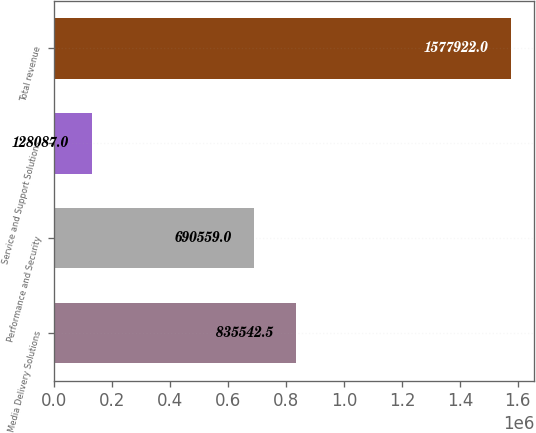<chart> <loc_0><loc_0><loc_500><loc_500><bar_chart><fcel>Media Delivery Solutions<fcel>Performance and Security<fcel>Service and Support Solutions<fcel>Total revenue<nl><fcel>835542<fcel>690559<fcel>128087<fcel>1.57792e+06<nl></chart> 